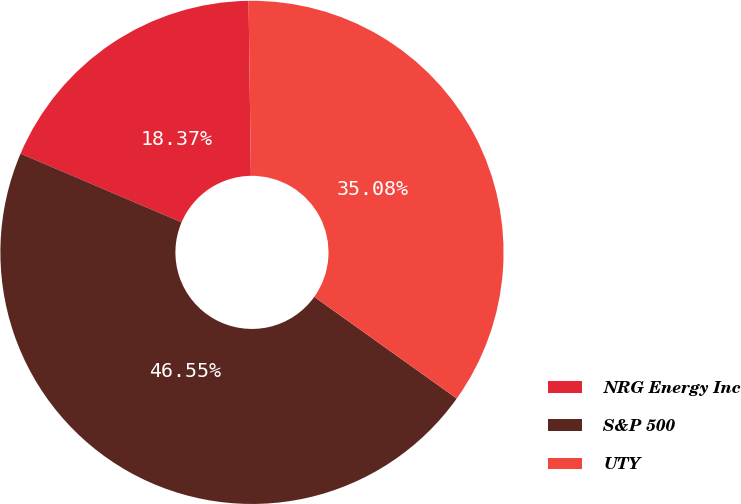Convert chart to OTSL. <chart><loc_0><loc_0><loc_500><loc_500><pie_chart><fcel>NRG Energy Inc<fcel>S&P 500<fcel>UTY<nl><fcel>18.37%<fcel>46.55%<fcel>35.08%<nl></chart> 